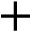Convert formula to latex. <formula><loc_0><loc_0><loc_500><loc_500>+</formula> 